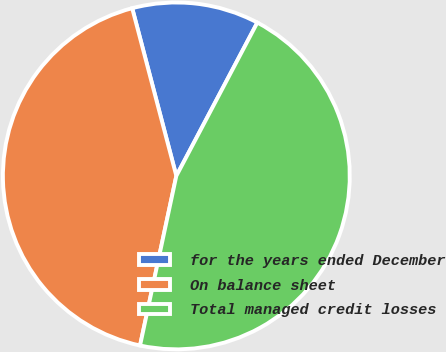Convert chart to OTSL. <chart><loc_0><loc_0><loc_500><loc_500><pie_chart><fcel>for the years ended December<fcel>On balance sheet<fcel>Total managed credit losses<nl><fcel>11.83%<fcel>42.55%<fcel>45.62%<nl></chart> 